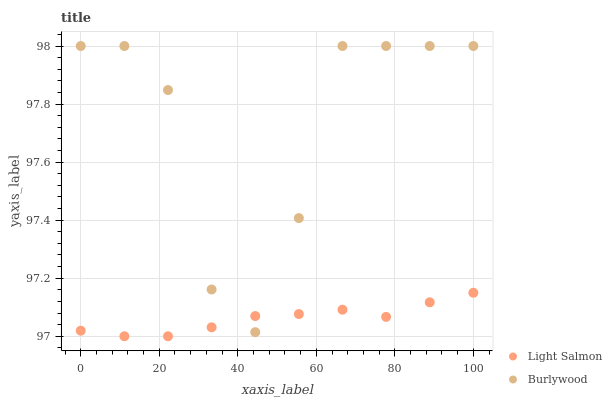Does Light Salmon have the minimum area under the curve?
Answer yes or no. Yes. Does Burlywood have the maximum area under the curve?
Answer yes or no. Yes. Does Light Salmon have the maximum area under the curve?
Answer yes or no. No. Is Light Salmon the smoothest?
Answer yes or no. Yes. Is Burlywood the roughest?
Answer yes or no. Yes. Is Light Salmon the roughest?
Answer yes or no. No. Does Light Salmon have the lowest value?
Answer yes or no. Yes. Does Burlywood have the highest value?
Answer yes or no. Yes. Does Light Salmon have the highest value?
Answer yes or no. No. Does Light Salmon intersect Burlywood?
Answer yes or no. Yes. Is Light Salmon less than Burlywood?
Answer yes or no. No. Is Light Salmon greater than Burlywood?
Answer yes or no. No. 